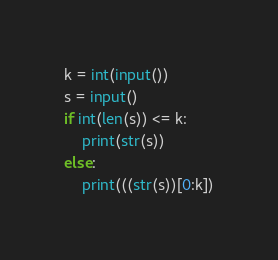<code> <loc_0><loc_0><loc_500><loc_500><_Python_>k = int(input())
s = input()
if int(len(s)) <= k:
  	print(str(s))
else:
  	print(((str(s))[0:k])</code> 